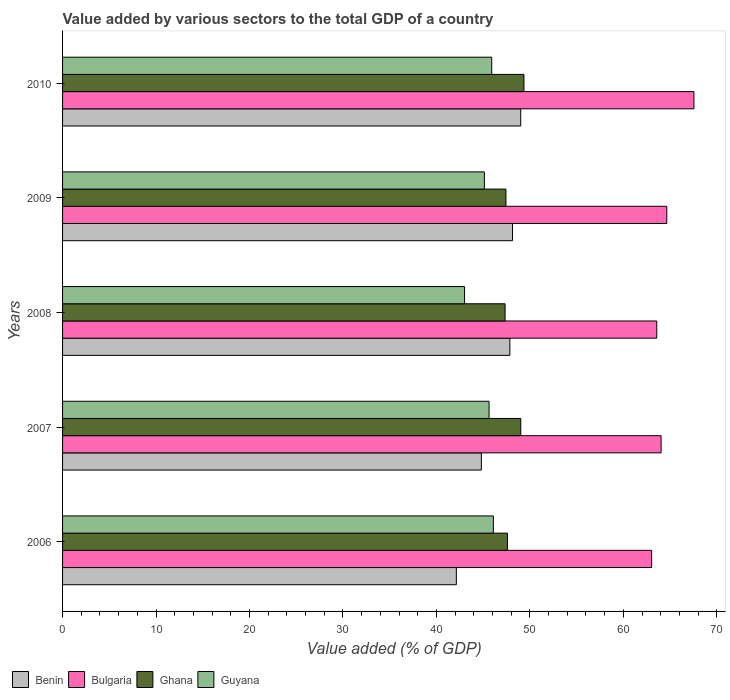How many different coloured bars are there?
Offer a very short reply. 4. How many groups of bars are there?
Offer a very short reply. 5. How many bars are there on the 2nd tick from the top?
Provide a succinct answer. 4. What is the label of the 2nd group of bars from the top?
Give a very brief answer. 2009. In how many cases, is the number of bars for a given year not equal to the number of legend labels?
Make the answer very short. 0. What is the value added by various sectors to the total GDP in Benin in 2010?
Offer a very short reply. 49.02. Across all years, what is the maximum value added by various sectors to the total GDP in Bulgaria?
Make the answer very short. 67.55. Across all years, what is the minimum value added by various sectors to the total GDP in Guyana?
Your answer should be very brief. 43.01. In which year was the value added by various sectors to the total GDP in Guyana maximum?
Give a very brief answer. 2006. What is the total value added by various sectors to the total GDP in Bulgaria in the graph?
Provide a short and direct response. 322.85. What is the difference between the value added by various sectors to the total GDP in Ghana in 2006 and that in 2009?
Ensure brevity in your answer.  0.16. What is the difference between the value added by various sectors to the total GDP in Ghana in 2009 and the value added by various sectors to the total GDP in Benin in 2007?
Your response must be concise. 2.63. What is the average value added by various sectors to the total GDP in Bulgaria per year?
Provide a succinct answer. 64.57. In the year 2009, what is the difference between the value added by various sectors to the total GDP in Guyana and value added by various sectors to the total GDP in Benin?
Provide a short and direct response. -3.01. In how many years, is the value added by various sectors to the total GDP in Guyana greater than 26 %?
Ensure brevity in your answer.  5. What is the ratio of the value added by various sectors to the total GDP in Bulgaria in 2008 to that in 2010?
Keep it short and to the point. 0.94. Is the difference between the value added by various sectors to the total GDP in Guyana in 2006 and 2009 greater than the difference between the value added by various sectors to the total GDP in Benin in 2006 and 2009?
Make the answer very short. Yes. What is the difference between the highest and the second highest value added by various sectors to the total GDP in Ghana?
Your answer should be very brief. 0.34. What is the difference between the highest and the lowest value added by various sectors to the total GDP in Ghana?
Your answer should be very brief. 2.02. Is the sum of the value added by various sectors to the total GDP in Bulgaria in 2006 and 2008 greater than the maximum value added by various sectors to the total GDP in Benin across all years?
Offer a very short reply. Yes. What does the 1st bar from the top in 2006 represents?
Give a very brief answer. Guyana. What does the 1st bar from the bottom in 2008 represents?
Offer a terse response. Benin. Is it the case that in every year, the sum of the value added by various sectors to the total GDP in Bulgaria and value added by various sectors to the total GDP in Ghana is greater than the value added by various sectors to the total GDP in Guyana?
Offer a terse response. Yes. How many bars are there?
Give a very brief answer. 20. Does the graph contain grids?
Your answer should be very brief. No. Where does the legend appear in the graph?
Keep it short and to the point. Bottom left. What is the title of the graph?
Your response must be concise. Value added by various sectors to the total GDP of a country. What is the label or title of the X-axis?
Make the answer very short. Value added (% of GDP). What is the Value added (% of GDP) of Benin in 2006?
Keep it short and to the point. 42.13. What is the Value added (% of GDP) in Bulgaria in 2006?
Provide a succinct answer. 63.03. What is the Value added (% of GDP) in Ghana in 2006?
Give a very brief answer. 47.6. What is the Value added (% of GDP) in Guyana in 2006?
Offer a very short reply. 46.09. What is the Value added (% of GDP) in Benin in 2007?
Keep it short and to the point. 44.81. What is the Value added (% of GDP) in Bulgaria in 2007?
Provide a succinct answer. 64.04. What is the Value added (% of GDP) of Ghana in 2007?
Ensure brevity in your answer.  49.03. What is the Value added (% of GDP) of Guyana in 2007?
Your response must be concise. 45.63. What is the Value added (% of GDP) in Benin in 2008?
Give a very brief answer. 47.86. What is the Value added (% of GDP) of Bulgaria in 2008?
Keep it short and to the point. 63.58. What is the Value added (% of GDP) in Ghana in 2008?
Make the answer very short. 47.35. What is the Value added (% of GDP) of Guyana in 2008?
Your response must be concise. 43.01. What is the Value added (% of GDP) of Benin in 2009?
Provide a succinct answer. 48.14. What is the Value added (% of GDP) of Bulgaria in 2009?
Keep it short and to the point. 64.65. What is the Value added (% of GDP) in Ghana in 2009?
Your answer should be compact. 47.44. What is the Value added (% of GDP) in Guyana in 2009?
Give a very brief answer. 45.13. What is the Value added (% of GDP) of Benin in 2010?
Your answer should be compact. 49.02. What is the Value added (% of GDP) of Bulgaria in 2010?
Your answer should be very brief. 67.55. What is the Value added (% of GDP) of Ghana in 2010?
Make the answer very short. 49.36. What is the Value added (% of GDP) in Guyana in 2010?
Keep it short and to the point. 45.92. Across all years, what is the maximum Value added (% of GDP) in Benin?
Your answer should be very brief. 49.02. Across all years, what is the maximum Value added (% of GDP) of Bulgaria?
Provide a succinct answer. 67.55. Across all years, what is the maximum Value added (% of GDP) in Ghana?
Your answer should be very brief. 49.36. Across all years, what is the maximum Value added (% of GDP) of Guyana?
Your answer should be very brief. 46.09. Across all years, what is the minimum Value added (% of GDP) in Benin?
Your response must be concise. 42.13. Across all years, what is the minimum Value added (% of GDP) in Bulgaria?
Your response must be concise. 63.03. Across all years, what is the minimum Value added (% of GDP) of Ghana?
Your answer should be very brief. 47.35. Across all years, what is the minimum Value added (% of GDP) in Guyana?
Offer a very short reply. 43.01. What is the total Value added (% of GDP) in Benin in the graph?
Keep it short and to the point. 231.95. What is the total Value added (% of GDP) of Bulgaria in the graph?
Give a very brief answer. 322.85. What is the total Value added (% of GDP) of Ghana in the graph?
Your answer should be very brief. 240.77. What is the total Value added (% of GDP) in Guyana in the graph?
Keep it short and to the point. 225.78. What is the difference between the Value added (% of GDP) in Benin in 2006 and that in 2007?
Ensure brevity in your answer.  -2.68. What is the difference between the Value added (% of GDP) of Bulgaria in 2006 and that in 2007?
Your response must be concise. -1.01. What is the difference between the Value added (% of GDP) in Ghana in 2006 and that in 2007?
Ensure brevity in your answer.  -1.43. What is the difference between the Value added (% of GDP) of Guyana in 2006 and that in 2007?
Ensure brevity in your answer.  0.46. What is the difference between the Value added (% of GDP) of Benin in 2006 and that in 2008?
Make the answer very short. -5.73. What is the difference between the Value added (% of GDP) of Bulgaria in 2006 and that in 2008?
Offer a very short reply. -0.55. What is the difference between the Value added (% of GDP) in Ghana in 2006 and that in 2008?
Your answer should be compact. 0.25. What is the difference between the Value added (% of GDP) in Guyana in 2006 and that in 2008?
Your response must be concise. 3.08. What is the difference between the Value added (% of GDP) in Benin in 2006 and that in 2009?
Give a very brief answer. -6.01. What is the difference between the Value added (% of GDP) in Bulgaria in 2006 and that in 2009?
Your answer should be very brief. -1.62. What is the difference between the Value added (% of GDP) in Ghana in 2006 and that in 2009?
Your answer should be compact. 0.16. What is the difference between the Value added (% of GDP) of Guyana in 2006 and that in 2009?
Provide a succinct answer. 0.96. What is the difference between the Value added (% of GDP) in Benin in 2006 and that in 2010?
Ensure brevity in your answer.  -6.89. What is the difference between the Value added (% of GDP) in Bulgaria in 2006 and that in 2010?
Keep it short and to the point. -4.52. What is the difference between the Value added (% of GDP) of Ghana in 2006 and that in 2010?
Make the answer very short. -1.77. What is the difference between the Value added (% of GDP) in Guyana in 2006 and that in 2010?
Offer a very short reply. 0.18. What is the difference between the Value added (% of GDP) in Benin in 2007 and that in 2008?
Keep it short and to the point. -3.05. What is the difference between the Value added (% of GDP) of Bulgaria in 2007 and that in 2008?
Provide a short and direct response. 0.46. What is the difference between the Value added (% of GDP) in Ghana in 2007 and that in 2008?
Provide a short and direct response. 1.68. What is the difference between the Value added (% of GDP) of Guyana in 2007 and that in 2008?
Your response must be concise. 2.62. What is the difference between the Value added (% of GDP) of Benin in 2007 and that in 2009?
Ensure brevity in your answer.  -3.33. What is the difference between the Value added (% of GDP) of Bulgaria in 2007 and that in 2009?
Your answer should be very brief. -0.61. What is the difference between the Value added (% of GDP) in Ghana in 2007 and that in 2009?
Your answer should be compact. 1.59. What is the difference between the Value added (% of GDP) in Guyana in 2007 and that in 2009?
Your answer should be compact. 0.5. What is the difference between the Value added (% of GDP) of Benin in 2007 and that in 2010?
Make the answer very short. -4.21. What is the difference between the Value added (% of GDP) of Bulgaria in 2007 and that in 2010?
Ensure brevity in your answer.  -3.51. What is the difference between the Value added (% of GDP) of Ghana in 2007 and that in 2010?
Make the answer very short. -0.34. What is the difference between the Value added (% of GDP) in Guyana in 2007 and that in 2010?
Your answer should be compact. -0.28. What is the difference between the Value added (% of GDP) of Benin in 2008 and that in 2009?
Offer a very short reply. -0.28. What is the difference between the Value added (% of GDP) of Bulgaria in 2008 and that in 2009?
Keep it short and to the point. -1.07. What is the difference between the Value added (% of GDP) in Ghana in 2008 and that in 2009?
Make the answer very short. -0.09. What is the difference between the Value added (% of GDP) in Guyana in 2008 and that in 2009?
Offer a very short reply. -2.12. What is the difference between the Value added (% of GDP) in Benin in 2008 and that in 2010?
Your response must be concise. -1.16. What is the difference between the Value added (% of GDP) of Bulgaria in 2008 and that in 2010?
Make the answer very short. -3.97. What is the difference between the Value added (% of GDP) in Ghana in 2008 and that in 2010?
Your response must be concise. -2.02. What is the difference between the Value added (% of GDP) in Guyana in 2008 and that in 2010?
Your answer should be very brief. -2.9. What is the difference between the Value added (% of GDP) in Benin in 2009 and that in 2010?
Your answer should be very brief. -0.88. What is the difference between the Value added (% of GDP) of Bulgaria in 2009 and that in 2010?
Your answer should be compact. -2.9. What is the difference between the Value added (% of GDP) of Ghana in 2009 and that in 2010?
Your response must be concise. -1.93. What is the difference between the Value added (% of GDP) in Guyana in 2009 and that in 2010?
Keep it short and to the point. -0.79. What is the difference between the Value added (% of GDP) in Benin in 2006 and the Value added (% of GDP) in Bulgaria in 2007?
Keep it short and to the point. -21.91. What is the difference between the Value added (% of GDP) of Benin in 2006 and the Value added (% of GDP) of Ghana in 2007?
Keep it short and to the point. -6.89. What is the difference between the Value added (% of GDP) in Benin in 2006 and the Value added (% of GDP) in Guyana in 2007?
Your response must be concise. -3.5. What is the difference between the Value added (% of GDP) of Bulgaria in 2006 and the Value added (% of GDP) of Ghana in 2007?
Your answer should be very brief. 14. What is the difference between the Value added (% of GDP) in Bulgaria in 2006 and the Value added (% of GDP) in Guyana in 2007?
Your response must be concise. 17.4. What is the difference between the Value added (% of GDP) in Ghana in 2006 and the Value added (% of GDP) in Guyana in 2007?
Your answer should be compact. 1.97. What is the difference between the Value added (% of GDP) of Benin in 2006 and the Value added (% of GDP) of Bulgaria in 2008?
Offer a very short reply. -21.44. What is the difference between the Value added (% of GDP) in Benin in 2006 and the Value added (% of GDP) in Ghana in 2008?
Offer a terse response. -5.22. What is the difference between the Value added (% of GDP) in Benin in 2006 and the Value added (% of GDP) in Guyana in 2008?
Keep it short and to the point. -0.88. What is the difference between the Value added (% of GDP) in Bulgaria in 2006 and the Value added (% of GDP) in Ghana in 2008?
Your answer should be compact. 15.68. What is the difference between the Value added (% of GDP) of Bulgaria in 2006 and the Value added (% of GDP) of Guyana in 2008?
Your response must be concise. 20.02. What is the difference between the Value added (% of GDP) of Ghana in 2006 and the Value added (% of GDP) of Guyana in 2008?
Your answer should be very brief. 4.59. What is the difference between the Value added (% of GDP) in Benin in 2006 and the Value added (% of GDP) in Bulgaria in 2009?
Keep it short and to the point. -22.52. What is the difference between the Value added (% of GDP) in Benin in 2006 and the Value added (% of GDP) in Ghana in 2009?
Provide a short and direct response. -5.3. What is the difference between the Value added (% of GDP) in Benin in 2006 and the Value added (% of GDP) in Guyana in 2009?
Offer a very short reply. -3. What is the difference between the Value added (% of GDP) of Bulgaria in 2006 and the Value added (% of GDP) of Ghana in 2009?
Your answer should be compact. 15.59. What is the difference between the Value added (% of GDP) of Bulgaria in 2006 and the Value added (% of GDP) of Guyana in 2009?
Give a very brief answer. 17.9. What is the difference between the Value added (% of GDP) of Ghana in 2006 and the Value added (% of GDP) of Guyana in 2009?
Provide a succinct answer. 2.47. What is the difference between the Value added (% of GDP) in Benin in 2006 and the Value added (% of GDP) in Bulgaria in 2010?
Ensure brevity in your answer.  -25.42. What is the difference between the Value added (% of GDP) of Benin in 2006 and the Value added (% of GDP) of Ghana in 2010?
Provide a succinct answer. -7.23. What is the difference between the Value added (% of GDP) in Benin in 2006 and the Value added (% of GDP) in Guyana in 2010?
Keep it short and to the point. -3.78. What is the difference between the Value added (% of GDP) in Bulgaria in 2006 and the Value added (% of GDP) in Ghana in 2010?
Your answer should be very brief. 13.66. What is the difference between the Value added (% of GDP) of Bulgaria in 2006 and the Value added (% of GDP) of Guyana in 2010?
Ensure brevity in your answer.  17.11. What is the difference between the Value added (% of GDP) in Ghana in 2006 and the Value added (% of GDP) in Guyana in 2010?
Your answer should be very brief. 1.68. What is the difference between the Value added (% of GDP) in Benin in 2007 and the Value added (% of GDP) in Bulgaria in 2008?
Ensure brevity in your answer.  -18.77. What is the difference between the Value added (% of GDP) of Benin in 2007 and the Value added (% of GDP) of Ghana in 2008?
Provide a short and direct response. -2.54. What is the difference between the Value added (% of GDP) in Benin in 2007 and the Value added (% of GDP) in Guyana in 2008?
Offer a terse response. 1.8. What is the difference between the Value added (% of GDP) of Bulgaria in 2007 and the Value added (% of GDP) of Ghana in 2008?
Provide a short and direct response. 16.69. What is the difference between the Value added (% of GDP) in Bulgaria in 2007 and the Value added (% of GDP) in Guyana in 2008?
Provide a short and direct response. 21.03. What is the difference between the Value added (% of GDP) of Ghana in 2007 and the Value added (% of GDP) of Guyana in 2008?
Give a very brief answer. 6.01. What is the difference between the Value added (% of GDP) in Benin in 2007 and the Value added (% of GDP) in Bulgaria in 2009?
Provide a short and direct response. -19.84. What is the difference between the Value added (% of GDP) of Benin in 2007 and the Value added (% of GDP) of Ghana in 2009?
Offer a very short reply. -2.63. What is the difference between the Value added (% of GDP) in Benin in 2007 and the Value added (% of GDP) in Guyana in 2009?
Provide a short and direct response. -0.32. What is the difference between the Value added (% of GDP) in Bulgaria in 2007 and the Value added (% of GDP) in Ghana in 2009?
Make the answer very short. 16.6. What is the difference between the Value added (% of GDP) in Bulgaria in 2007 and the Value added (% of GDP) in Guyana in 2009?
Provide a short and direct response. 18.91. What is the difference between the Value added (% of GDP) in Ghana in 2007 and the Value added (% of GDP) in Guyana in 2009?
Your response must be concise. 3.9. What is the difference between the Value added (% of GDP) in Benin in 2007 and the Value added (% of GDP) in Bulgaria in 2010?
Provide a succinct answer. -22.74. What is the difference between the Value added (% of GDP) of Benin in 2007 and the Value added (% of GDP) of Ghana in 2010?
Offer a terse response. -4.56. What is the difference between the Value added (% of GDP) in Benin in 2007 and the Value added (% of GDP) in Guyana in 2010?
Keep it short and to the point. -1.11. What is the difference between the Value added (% of GDP) in Bulgaria in 2007 and the Value added (% of GDP) in Ghana in 2010?
Offer a very short reply. 14.68. What is the difference between the Value added (% of GDP) in Bulgaria in 2007 and the Value added (% of GDP) in Guyana in 2010?
Give a very brief answer. 18.12. What is the difference between the Value added (% of GDP) of Ghana in 2007 and the Value added (% of GDP) of Guyana in 2010?
Give a very brief answer. 3.11. What is the difference between the Value added (% of GDP) of Benin in 2008 and the Value added (% of GDP) of Bulgaria in 2009?
Your response must be concise. -16.79. What is the difference between the Value added (% of GDP) of Benin in 2008 and the Value added (% of GDP) of Ghana in 2009?
Make the answer very short. 0.42. What is the difference between the Value added (% of GDP) in Benin in 2008 and the Value added (% of GDP) in Guyana in 2009?
Provide a succinct answer. 2.73. What is the difference between the Value added (% of GDP) in Bulgaria in 2008 and the Value added (% of GDP) in Ghana in 2009?
Your response must be concise. 16.14. What is the difference between the Value added (% of GDP) in Bulgaria in 2008 and the Value added (% of GDP) in Guyana in 2009?
Your response must be concise. 18.45. What is the difference between the Value added (% of GDP) of Ghana in 2008 and the Value added (% of GDP) of Guyana in 2009?
Provide a succinct answer. 2.22. What is the difference between the Value added (% of GDP) in Benin in 2008 and the Value added (% of GDP) in Bulgaria in 2010?
Offer a very short reply. -19.69. What is the difference between the Value added (% of GDP) in Benin in 2008 and the Value added (% of GDP) in Ghana in 2010?
Keep it short and to the point. -1.51. What is the difference between the Value added (% of GDP) in Benin in 2008 and the Value added (% of GDP) in Guyana in 2010?
Keep it short and to the point. 1.94. What is the difference between the Value added (% of GDP) of Bulgaria in 2008 and the Value added (% of GDP) of Ghana in 2010?
Provide a succinct answer. 14.21. What is the difference between the Value added (% of GDP) in Bulgaria in 2008 and the Value added (% of GDP) in Guyana in 2010?
Provide a succinct answer. 17.66. What is the difference between the Value added (% of GDP) in Ghana in 2008 and the Value added (% of GDP) in Guyana in 2010?
Offer a terse response. 1.43. What is the difference between the Value added (% of GDP) in Benin in 2009 and the Value added (% of GDP) in Bulgaria in 2010?
Your answer should be very brief. -19.41. What is the difference between the Value added (% of GDP) in Benin in 2009 and the Value added (% of GDP) in Ghana in 2010?
Ensure brevity in your answer.  -1.23. What is the difference between the Value added (% of GDP) of Benin in 2009 and the Value added (% of GDP) of Guyana in 2010?
Offer a terse response. 2.22. What is the difference between the Value added (% of GDP) of Bulgaria in 2009 and the Value added (% of GDP) of Ghana in 2010?
Your answer should be compact. 15.28. What is the difference between the Value added (% of GDP) in Bulgaria in 2009 and the Value added (% of GDP) in Guyana in 2010?
Keep it short and to the point. 18.73. What is the difference between the Value added (% of GDP) of Ghana in 2009 and the Value added (% of GDP) of Guyana in 2010?
Keep it short and to the point. 1.52. What is the average Value added (% of GDP) of Benin per year?
Ensure brevity in your answer.  46.39. What is the average Value added (% of GDP) in Bulgaria per year?
Your answer should be compact. 64.57. What is the average Value added (% of GDP) of Ghana per year?
Offer a terse response. 48.15. What is the average Value added (% of GDP) in Guyana per year?
Your response must be concise. 45.16. In the year 2006, what is the difference between the Value added (% of GDP) in Benin and Value added (% of GDP) in Bulgaria?
Ensure brevity in your answer.  -20.9. In the year 2006, what is the difference between the Value added (% of GDP) in Benin and Value added (% of GDP) in Ghana?
Your response must be concise. -5.47. In the year 2006, what is the difference between the Value added (% of GDP) in Benin and Value added (% of GDP) in Guyana?
Offer a very short reply. -3.96. In the year 2006, what is the difference between the Value added (% of GDP) in Bulgaria and Value added (% of GDP) in Ghana?
Your answer should be compact. 15.43. In the year 2006, what is the difference between the Value added (% of GDP) in Bulgaria and Value added (% of GDP) in Guyana?
Make the answer very short. 16.94. In the year 2006, what is the difference between the Value added (% of GDP) of Ghana and Value added (% of GDP) of Guyana?
Make the answer very short. 1.51. In the year 2007, what is the difference between the Value added (% of GDP) in Benin and Value added (% of GDP) in Bulgaria?
Your answer should be very brief. -19.23. In the year 2007, what is the difference between the Value added (% of GDP) in Benin and Value added (% of GDP) in Ghana?
Give a very brief answer. -4.22. In the year 2007, what is the difference between the Value added (% of GDP) in Benin and Value added (% of GDP) in Guyana?
Your response must be concise. -0.82. In the year 2007, what is the difference between the Value added (% of GDP) of Bulgaria and Value added (% of GDP) of Ghana?
Give a very brief answer. 15.01. In the year 2007, what is the difference between the Value added (% of GDP) in Bulgaria and Value added (% of GDP) in Guyana?
Your answer should be very brief. 18.41. In the year 2007, what is the difference between the Value added (% of GDP) of Ghana and Value added (% of GDP) of Guyana?
Your response must be concise. 3.39. In the year 2008, what is the difference between the Value added (% of GDP) in Benin and Value added (% of GDP) in Bulgaria?
Make the answer very short. -15.72. In the year 2008, what is the difference between the Value added (% of GDP) of Benin and Value added (% of GDP) of Ghana?
Make the answer very short. 0.51. In the year 2008, what is the difference between the Value added (% of GDP) of Benin and Value added (% of GDP) of Guyana?
Ensure brevity in your answer.  4.85. In the year 2008, what is the difference between the Value added (% of GDP) of Bulgaria and Value added (% of GDP) of Ghana?
Give a very brief answer. 16.23. In the year 2008, what is the difference between the Value added (% of GDP) of Bulgaria and Value added (% of GDP) of Guyana?
Provide a succinct answer. 20.57. In the year 2008, what is the difference between the Value added (% of GDP) in Ghana and Value added (% of GDP) in Guyana?
Keep it short and to the point. 4.34. In the year 2009, what is the difference between the Value added (% of GDP) of Benin and Value added (% of GDP) of Bulgaria?
Provide a succinct answer. -16.51. In the year 2009, what is the difference between the Value added (% of GDP) in Benin and Value added (% of GDP) in Ghana?
Your answer should be very brief. 0.7. In the year 2009, what is the difference between the Value added (% of GDP) of Benin and Value added (% of GDP) of Guyana?
Keep it short and to the point. 3.01. In the year 2009, what is the difference between the Value added (% of GDP) in Bulgaria and Value added (% of GDP) in Ghana?
Ensure brevity in your answer.  17.21. In the year 2009, what is the difference between the Value added (% of GDP) in Bulgaria and Value added (% of GDP) in Guyana?
Give a very brief answer. 19.52. In the year 2009, what is the difference between the Value added (% of GDP) in Ghana and Value added (% of GDP) in Guyana?
Provide a succinct answer. 2.31. In the year 2010, what is the difference between the Value added (% of GDP) of Benin and Value added (% of GDP) of Bulgaria?
Make the answer very short. -18.53. In the year 2010, what is the difference between the Value added (% of GDP) in Benin and Value added (% of GDP) in Ghana?
Your response must be concise. -0.35. In the year 2010, what is the difference between the Value added (% of GDP) in Benin and Value added (% of GDP) in Guyana?
Offer a very short reply. 3.1. In the year 2010, what is the difference between the Value added (% of GDP) in Bulgaria and Value added (% of GDP) in Ghana?
Give a very brief answer. 18.19. In the year 2010, what is the difference between the Value added (% of GDP) in Bulgaria and Value added (% of GDP) in Guyana?
Provide a succinct answer. 21.63. In the year 2010, what is the difference between the Value added (% of GDP) in Ghana and Value added (% of GDP) in Guyana?
Keep it short and to the point. 3.45. What is the ratio of the Value added (% of GDP) in Benin in 2006 to that in 2007?
Your answer should be compact. 0.94. What is the ratio of the Value added (% of GDP) in Bulgaria in 2006 to that in 2007?
Keep it short and to the point. 0.98. What is the ratio of the Value added (% of GDP) in Ghana in 2006 to that in 2007?
Your answer should be compact. 0.97. What is the ratio of the Value added (% of GDP) of Guyana in 2006 to that in 2007?
Provide a short and direct response. 1.01. What is the ratio of the Value added (% of GDP) of Benin in 2006 to that in 2008?
Keep it short and to the point. 0.88. What is the ratio of the Value added (% of GDP) in Guyana in 2006 to that in 2008?
Provide a succinct answer. 1.07. What is the ratio of the Value added (% of GDP) in Benin in 2006 to that in 2009?
Provide a succinct answer. 0.88. What is the ratio of the Value added (% of GDP) of Bulgaria in 2006 to that in 2009?
Give a very brief answer. 0.97. What is the ratio of the Value added (% of GDP) of Guyana in 2006 to that in 2009?
Your answer should be very brief. 1.02. What is the ratio of the Value added (% of GDP) in Benin in 2006 to that in 2010?
Your response must be concise. 0.86. What is the ratio of the Value added (% of GDP) in Bulgaria in 2006 to that in 2010?
Keep it short and to the point. 0.93. What is the ratio of the Value added (% of GDP) in Ghana in 2006 to that in 2010?
Your answer should be very brief. 0.96. What is the ratio of the Value added (% of GDP) in Benin in 2007 to that in 2008?
Your answer should be compact. 0.94. What is the ratio of the Value added (% of GDP) of Bulgaria in 2007 to that in 2008?
Provide a succinct answer. 1.01. What is the ratio of the Value added (% of GDP) in Ghana in 2007 to that in 2008?
Give a very brief answer. 1.04. What is the ratio of the Value added (% of GDP) in Guyana in 2007 to that in 2008?
Provide a succinct answer. 1.06. What is the ratio of the Value added (% of GDP) of Benin in 2007 to that in 2009?
Keep it short and to the point. 0.93. What is the ratio of the Value added (% of GDP) of Bulgaria in 2007 to that in 2009?
Offer a very short reply. 0.99. What is the ratio of the Value added (% of GDP) of Ghana in 2007 to that in 2009?
Offer a terse response. 1.03. What is the ratio of the Value added (% of GDP) in Guyana in 2007 to that in 2009?
Offer a very short reply. 1.01. What is the ratio of the Value added (% of GDP) in Benin in 2007 to that in 2010?
Your answer should be compact. 0.91. What is the ratio of the Value added (% of GDP) of Bulgaria in 2007 to that in 2010?
Ensure brevity in your answer.  0.95. What is the ratio of the Value added (% of GDP) in Ghana in 2007 to that in 2010?
Your response must be concise. 0.99. What is the ratio of the Value added (% of GDP) in Guyana in 2007 to that in 2010?
Provide a succinct answer. 0.99. What is the ratio of the Value added (% of GDP) in Benin in 2008 to that in 2009?
Give a very brief answer. 0.99. What is the ratio of the Value added (% of GDP) of Bulgaria in 2008 to that in 2009?
Provide a succinct answer. 0.98. What is the ratio of the Value added (% of GDP) in Ghana in 2008 to that in 2009?
Provide a succinct answer. 1. What is the ratio of the Value added (% of GDP) in Guyana in 2008 to that in 2009?
Your answer should be compact. 0.95. What is the ratio of the Value added (% of GDP) of Benin in 2008 to that in 2010?
Your answer should be very brief. 0.98. What is the ratio of the Value added (% of GDP) of Bulgaria in 2008 to that in 2010?
Your response must be concise. 0.94. What is the ratio of the Value added (% of GDP) in Ghana in 2008 to that in 2010?
Keep it short and to the point. 0.96. What is the ratio of the Value added (% of GDP) of Guyana in 2008 to that in 2010?
Give a very brief answer. 0.94. What is the ratio of the Value added (% of GDP) of Benin in 2009 to that in 2010?
Offer a terse response. 0.98. What is the ratio of the Value added (% of GDP) in Bulgaria in 2009 to that in 2010?
Make the answer very short. 0.96. What is the ratio of the Value added (% of GDP) in Ghana in 2009 to that in 2010?
Make the answer very short. 0.96. What is the ratio of the Value added (% of GDP) of Guyana in 2009 to that in 2010?
Provide a short and direct response. 0.98. What is the difference between the highest and the second highest Value added (% of GDP) in Bulgaria?
Provide a succinct answer. 2.9. What is the difference between the highest and the second highest Value added (% of GDP) of Ghana?
Ensure brevity in your answer.  0.34. What is the difference between the highest and the second highest Value added (% of GDP) of Guyana?
Ensure brevity in your answer.  0.18. What is the difference between the highest and the lowest Value added (% of GDP) of Benin?
Your answer should be very brief. 6.89. What is the difference between the highest and the lowest Value added (% of GDP) of Bulgaria?
Keep it short and to the point. 4.52. What is the difference between the highest and the lowest Value added (% of GDP) in Ghana?
Your response must be concise. 2.02. What is the difference between the highest and the lowest Value added (% of GDP) in Guyana?
Your answer should be very brief. 3.08. 